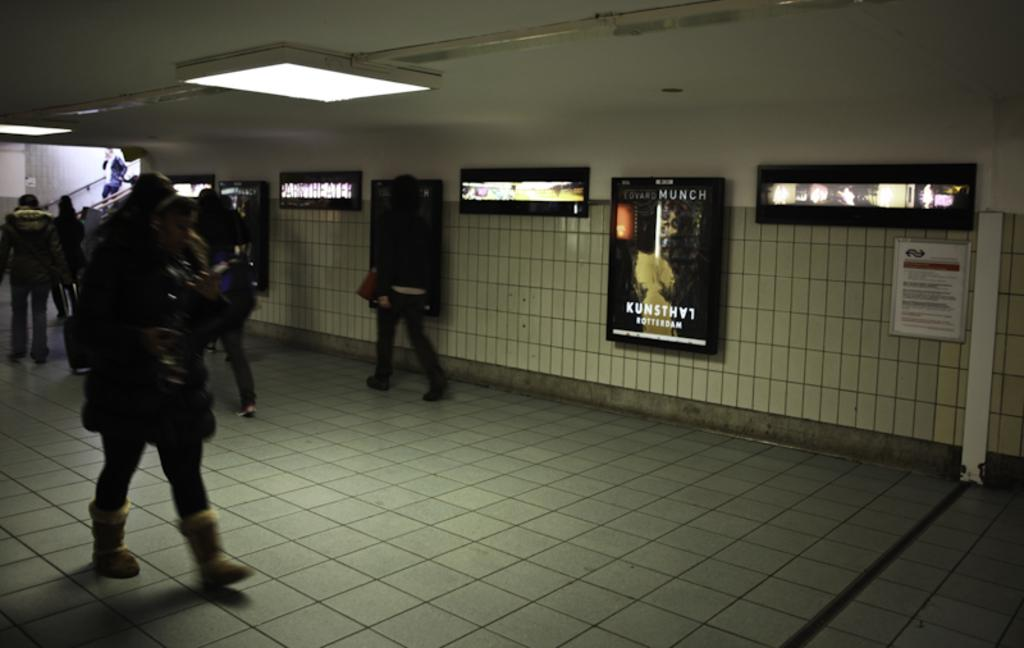How many people are in the image? There is a group of people in the image. What are the people doing in the image? The people are walking on the floor. What can be seen on the wall in the image? There is a wall with boards attached to it in the image. What is present on the ceiling in the image? There are lights attached to the ceiling in the image. Can you tell me where the drum is located in the image? There is no drum present in the image. How many family members can be seen in the image? The provided facts do not mention any family members, so it cannot be determined from the image. 